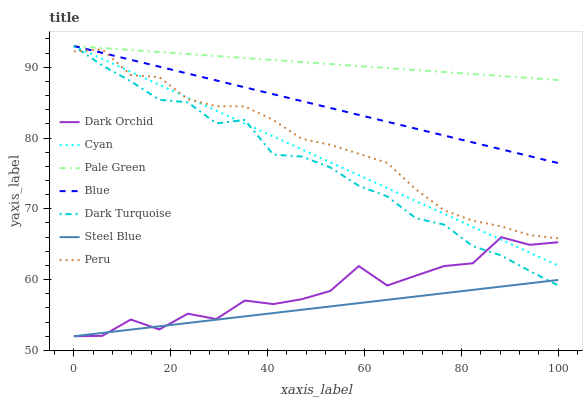Does Steel Blue have the minimum area under the curve?
Answer yes or no. Yes. Does Pale Green have the maximum area under the curve?
Answer yes or no. Yes. Does Dark Turquoise have the minimum area under the curve?
Answer yes or no. No. Does Dark Turquoise have the maximum area under the curve?
Answer yes or no. No. Is Steel Blue the smoothest?
Answer yes or no. Yes. Is Dark Orchid the roughest?
Answer yes or no. Yes. Is Dark Turquoise the smoothest?
Answer yes or no. No. Is Dark Turquoise the roughest?
Answer yes or no. No. Does Steel Blue have the lowest value?
Answer yes or no. Yes. Does Dark Turquoise have the lowest value?
Answer yes or no. No. Does Cyan have the highest value?
Answer yes or no. Yes. Does Steel Blue have the highest value?
Answer yes or no. No. Is Dark Orchid less than Blue?
Answer yes or no. Yes. Is Peru greater than Steel Blue?
Answer yes or no. Yes. Does Steel Blue intersect Dark Orchid?
Answer yes or no. Yes. Is Steel Blue less than Dark Orchid?
Answer yes or no. No. Is Steel Blue greater than Dark Orchid?
Answer yes or no. No. Does Dark Orchid intersect Blue?
Answer yes or no. No. 